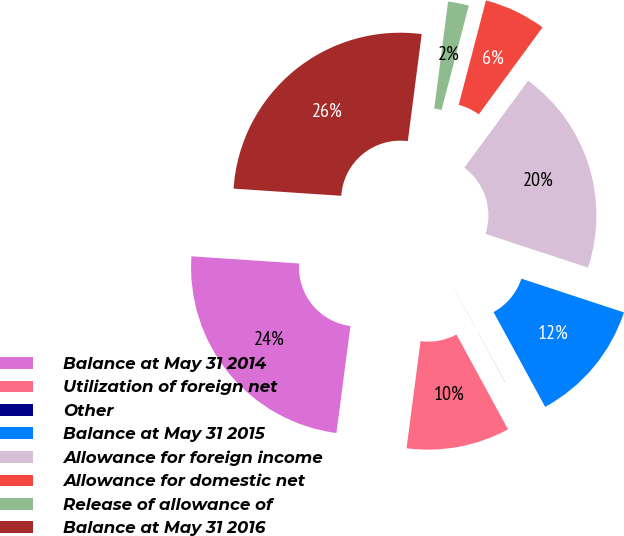Convert chart. <chart><loc_0><loc_0><loc_500><loc_500><pie_chart><fcel>Balance at May 31 2014<fcel>Utilization of foreign net<fcel>Other<fcel>Balance at May 31 2015<fcel>Allowance for foreign income<fcel>Allowance for domestic net<fcel>Release of allowance of<fcel>Balance at May 31 2016<nl><fcel>23.99%<fcel>10.0%<fcel>0.01%<fcel>12.0%<fcel>19.99%<fcel>6.01%<fcel>2.01%<fcel>25.99%<nl></chart> 